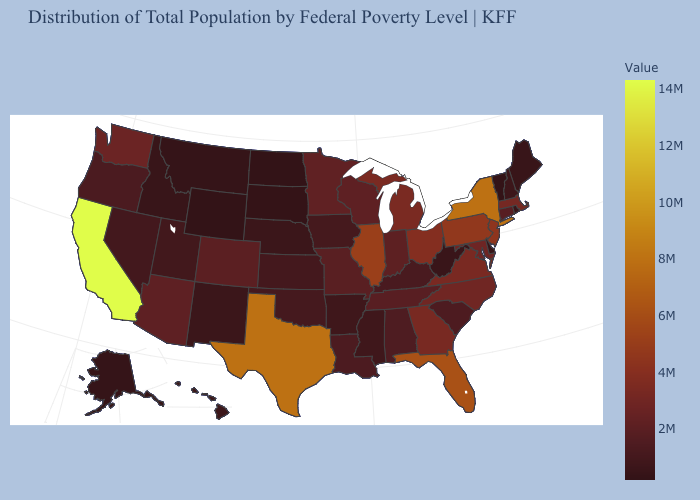Among the states that border Nebraska , does Colorado have the highest value?
Quick response, please. Yes. Which states have the lowest value in the MidWest?
Short answer required. North Dakota. Is the legend a continuous bar?
Keep it brief. Yes. Does the map have missing data?
Give a very brief answer. No. Among the states that border Kansas , does Nebraska have the lowest value?
Write a very short answer. Yes. Among the states that border South Dakota , does Minnesota have the lowest value?
Concise answer only. No. 